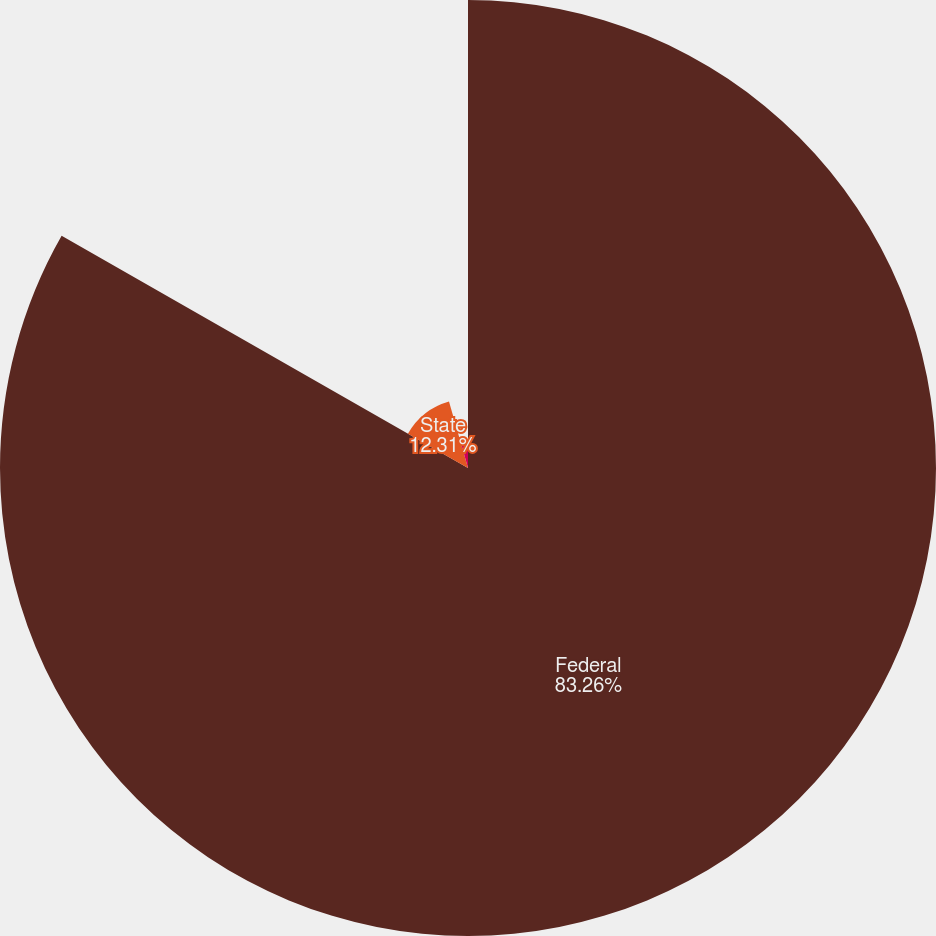Convert chart to OTSL. <chart><loc_0><loc_0><loc_500><loc_500><pie_chart><fcel>Federal<fcel>State<fcel>Foreign<nl><fcel>83.26%<fcel>12.31%<fcel>4.43%<nl></chart> 